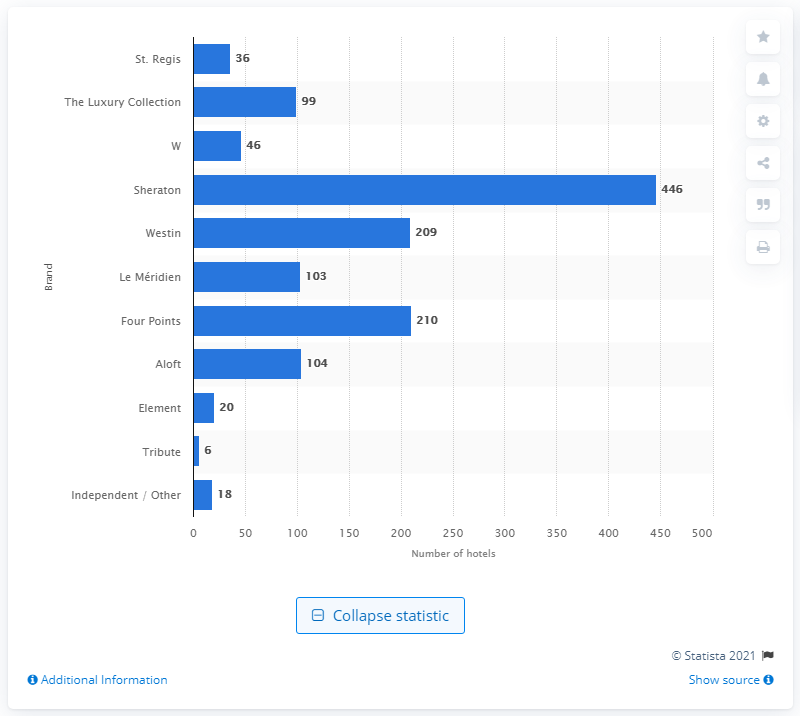Outline some significant characteristics in this image. In 2015, there were 210 properties in the Starwood Hotels & Resorts portfolio that were classified as Four Points properties. 